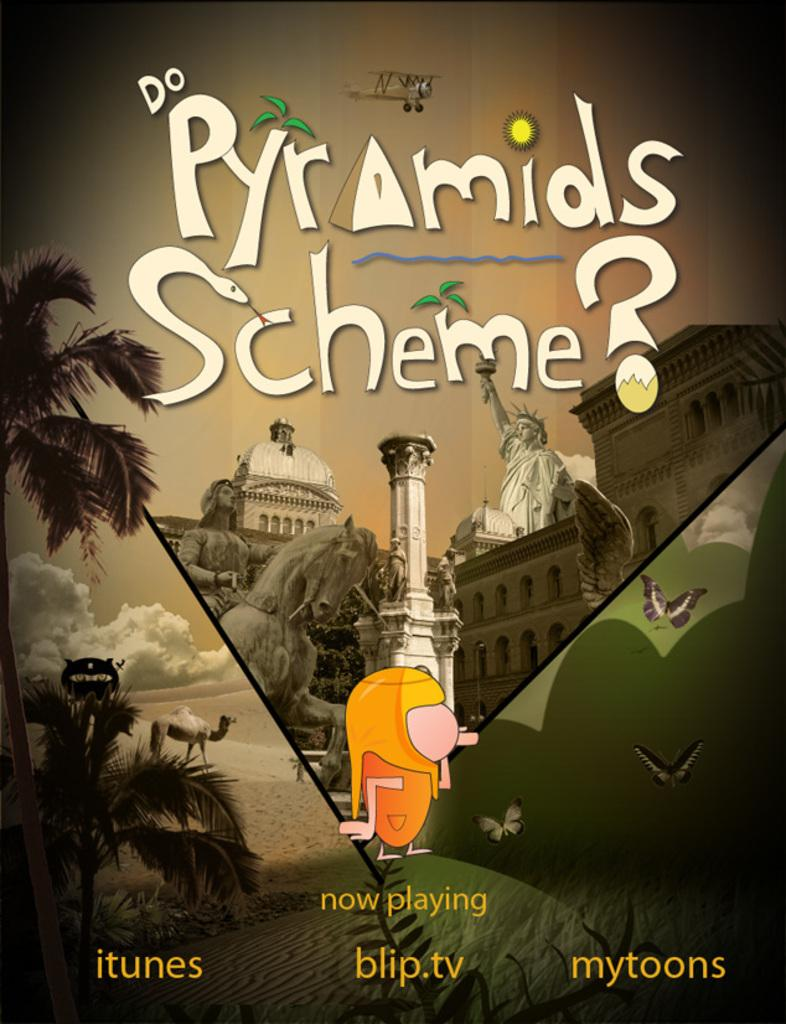<image>
Present a compact description of the photo's key features. a itunes blip.tv mytoons advertisement entitled Do Pyramids Scheme? with statues and other graphics. 